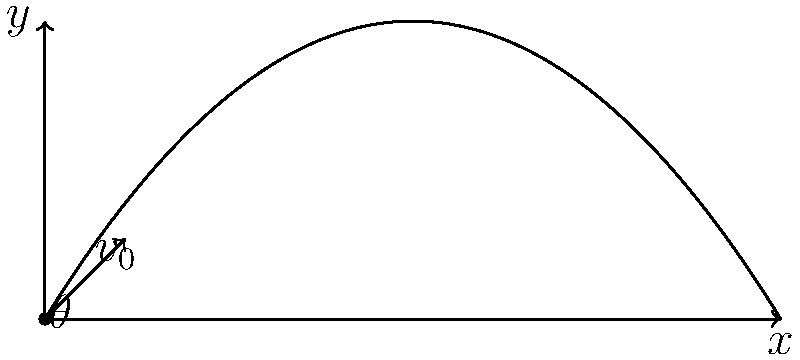A running back needs to leap over a defensive player to gain crucial yards. Given an initial velocity of 10 m/s, calculate the optimal angle $\theta$ for the running back to achieve maximum horizontal distance. Assume the defensive player is 1.8 meters tall and neglect air resistance. How far horizontally will the running back travel before landing? To solve this problem, we'll follow these steps:

1) The optimal angle for maximum horizontal distance is 45°. This is true for all projectile motions in a uniform gravitational field without air resistance.

2) The horizontal distance (range) for a projectile is given by:
   $$R = \frac{v_0^2 \sin(2\theta)}{g}$$

   Where $v_0$ is the initial velocity, $\theta$ is the launch angle, and $g$ is the acceleration due to gravity (9.8 m/s^2).

3) Substituting the values:
   $$R = \frac{(10 \text{ m/s})^2 \sin(2 \cdot 45°)}{9.8 \text{ m/s}^2}$$

4) Simplify:
   $$R = \frac{100 \cdot 1}{9.8} = 10.20 \text{ m}$$

5) To verify if this clears the defensive player, we need to calculate the maximum height:
   $$h_{\text{max}} = \frac{v_0^2 \sin^2(\theta)}{2g}$$

6) Substituting values:
   $$h_{\text{max}} = \frac{(10 \text{ m/s})^2 \sin^2(45°)}{2 \cdot 9.8 \text{ m/s}^2} = 2.55 \text{ m}$$

7) Since 2.55 m > 1.8 m, the running back will clear the defensive player.

Therefore, the running back will travel 10.20 meters horizontally before landing, successfully clearing the 1.8-meter tall defensive player.
Answer: 10.20 meters 